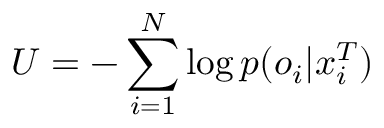Convert formula to latex. <formula><loc_0><loc_0><loc_500><loc_500>U = - \sum _ { i = 1 } ^ { N } \log p ( o _ { i } | x _ { i } ^ { T } )</formula> 